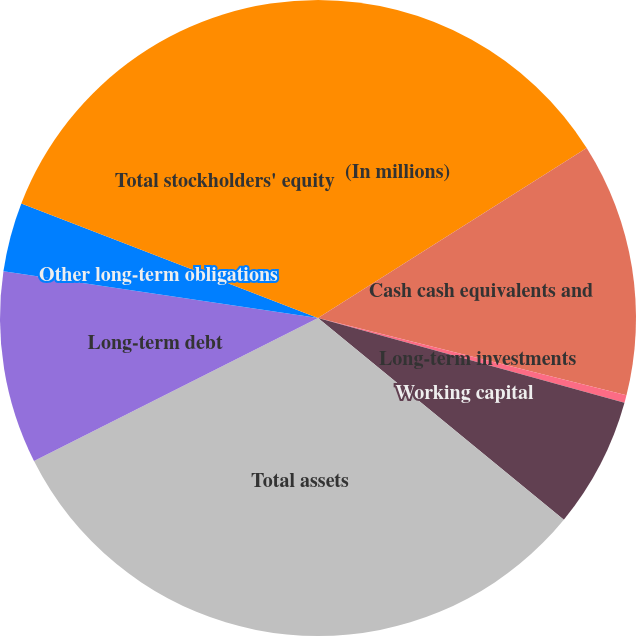<chart> <loc_0><loc_0><loc_500><loc_500><pie_chart><fcel>(In millions)<fcel>Cash cash equivalents and<fcel>Long-term investments<fcel>Working capital<fcel>Total assets<fcel>Long-term debt<fcel>Other long-term obligations<fcel>Total stockholders' equity<nl><fcel>16.02%<fcel>12.89%<fcel>0.39%<fcel>6.64%<fcel>31.64%<fcel>9.77%<fcel>3.52%<fcel>19.14%<nl></chart> 